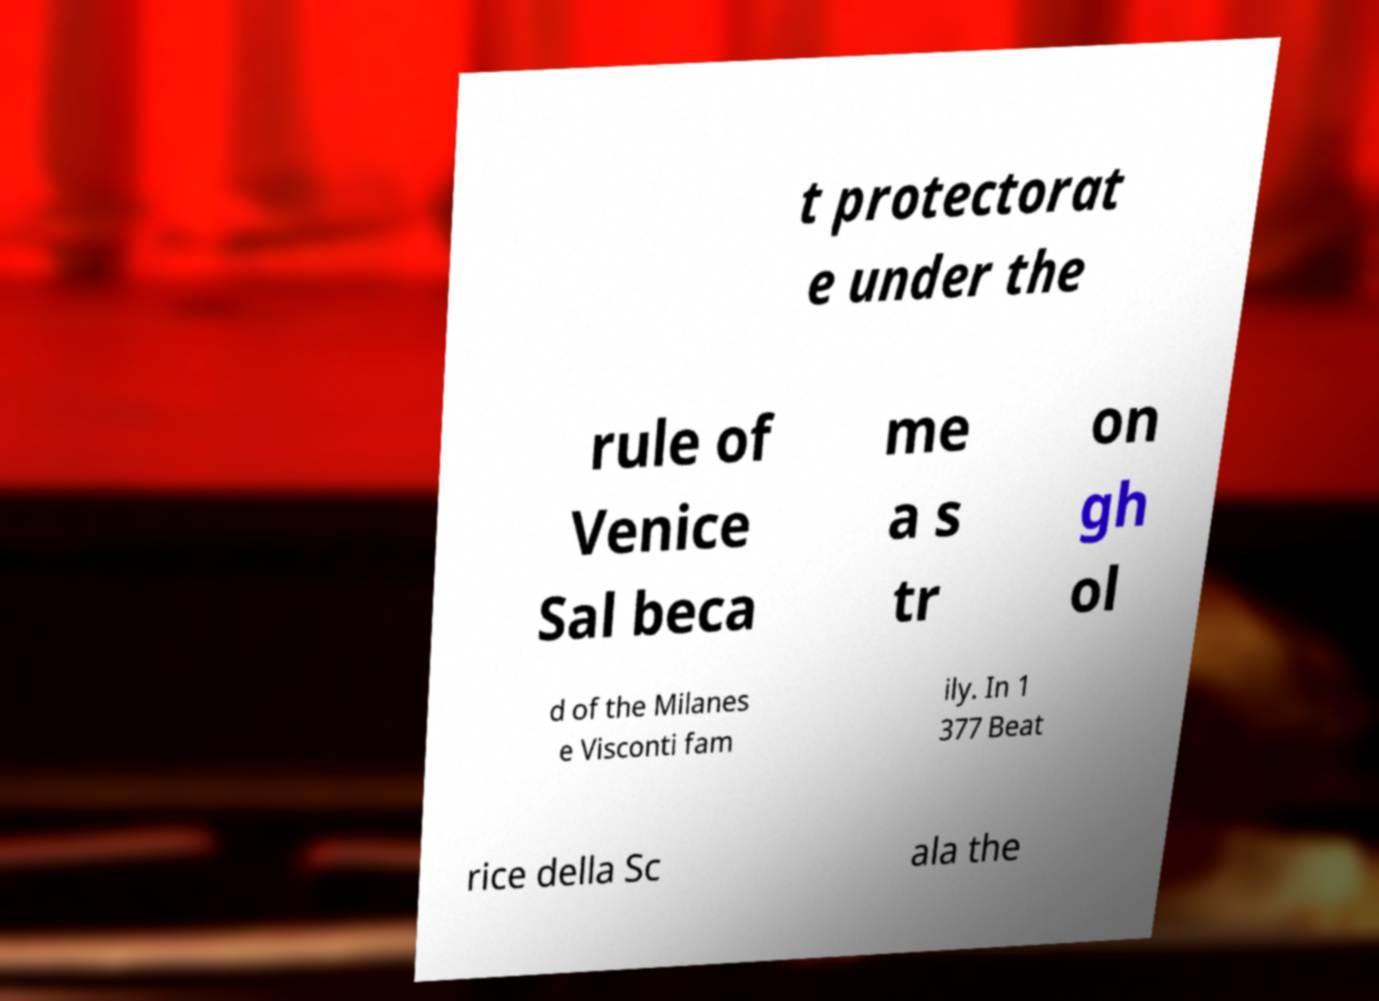What messages or text are displayed in this image? I need them in a readable, typed format. t protectorat e under the rule of Venice Sal beca me a s tr on gh ol d of the Milanes e Visconti fam ily. In 1 377 Beat rice della Sc ala the 